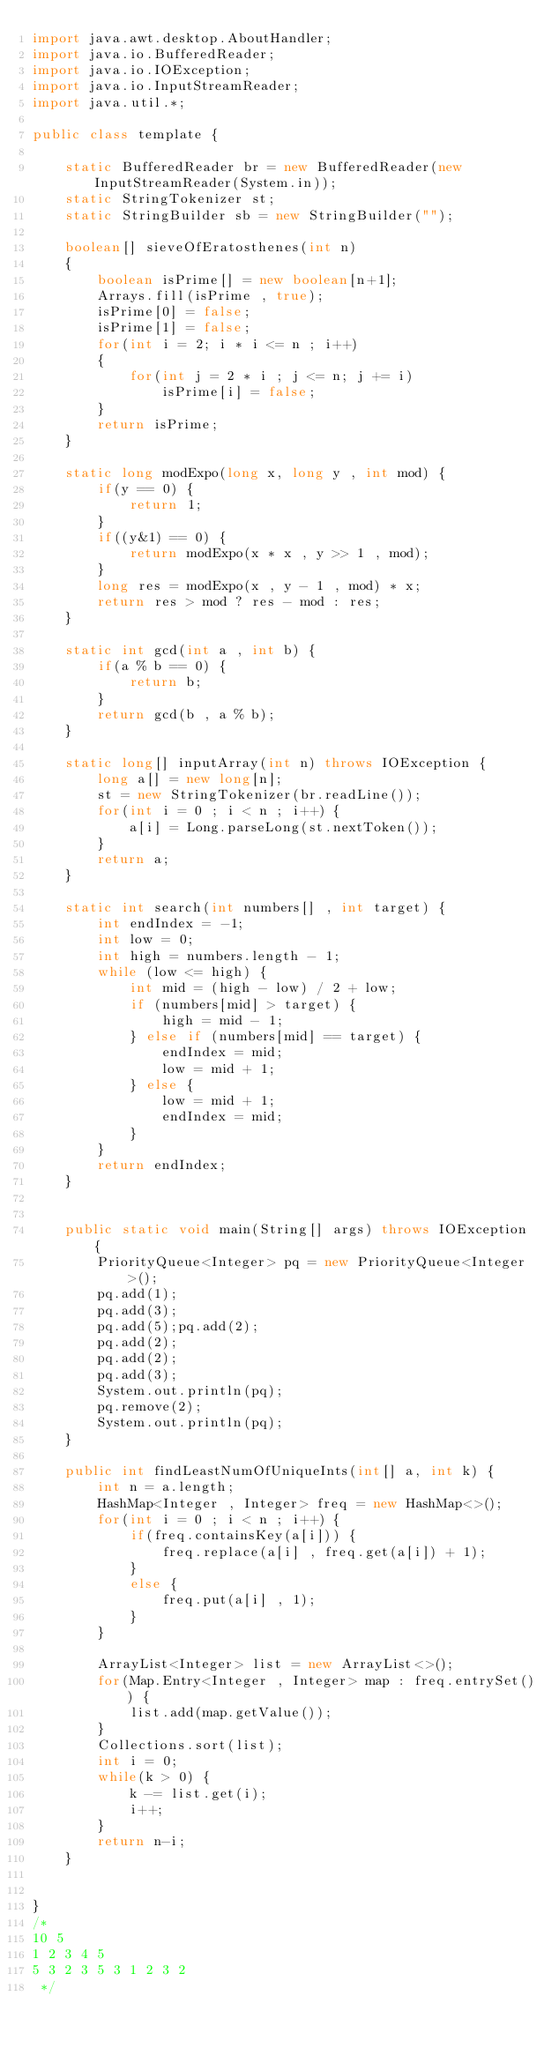<code> <loc_0><loc_0><loc_500><loc_500><_Java_>import java.awt.desktop.AboutHandler;
import java.io.BufferedReader;
import java.io.IOException;
import java.io.InputStreamReader;
import java.util.*;

public class template {

    static BufferedReader br = new BufferedReader(new InputStreamReader(System.in));
    static StringTokenizer st;
    static StringBuilder sb = new StringBuilder("");

    boolean[] sieveOfEratosthenes(int n)
    {
        boolean isPrime[] = new boolean[n+1];
        Arrays.fill(isPrime , true);
        isPrime[0] = false;
        isPrime[1] = false;
        for(int i = 2; i * i <= n ; i++)
        {
            for(int j = 2 * i ; j <= n; j += i)
                isPrime[i] = false;
        }
        return isPrime;
    }

    static long modExpo(long x, long y , int mod) {
        if(y == 0) {
            return 1;
        }
        if((y&1) == 0) {
            return modExpo(x * x , y >> 1 , mod);
        }
        long res = modExpo(x , y - 1 , mod) * x;
        return res > mod ? res - mod : res;
    }

    static int gcd(int a , int b) {
        if(a % b == 0) {
            return b;
        }
        return gcd(b , a % b);
    }

    static long[] inputArray(int n) throws IOException {
        long a[] = new long[n];
        st = new StringTokenizer(br.readLine());
        for(int i = 0 ; i < n ; i++) {
            a[i] = Long.parseLong(st.nextToken());
        }
        return a;
    }

    static int search(int numbers[] , int target) {
        int endIndex = -1;
        int low = 0;
        int high = numbers.length - 1;
        while (low <= high) {
            int mid = (high - low) / 2 + low;
            if (numbers[mid] > target) {
                high = mid - 1;
            } else if (numbers[mid] == target) {
                endIndex = mid;
                low = mid + 1;
            } else {
                low = mid + 1;
                endIndex = mid;
            }
        }
        return endIndex;
    }


    public static void main(String[] args) throws IOException {
        PriorityQueue<Integer> pq = new PriorityQueue<Integer>();
        pq.add(1);
        pq.add(3);
        pq.add(5);pq.add(2);
        pq.add(2);
        pq.add(2);
        pq.add(3);
        System.out.println(pq);
        pq.remove(2);
        System.out.println(pq);
    }

    public int findLeastNumOfUniqueInts(int[] a, int k) {
        int n = a.length;
        HashMap<Integer , Integer> freq = new HashMap<>();
        for(int i = 0 ; i < n ; i++) {
            if(freq.containsKey(a[i])) {
                freq.replace(a[i] , freq.get(a[i]) + 1);
            }
            else {
                freq.put(a[i] , 1);
            }
        }

        ArrayList<Integer> list = new ArrayList<>();
        for(Map.Entry<Integer , Integer> map : freq.entrySet()) {
            list.add(map.getValue());
        }
        Collections.sort(list);
        int i = 0;
        while(k > 0) {
            k -= list.get(i);
            i++;
        }
        return n-i;
    }


}
/*
10 5
1 2 3 4 5
5 3 2 3 5 3 1 2 3 2
 */</code> 